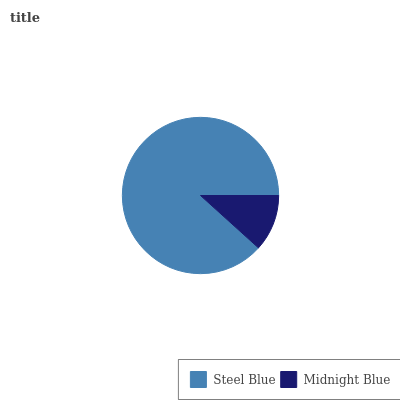Is Midnight Blue the minimum?
Answer yes or no. Yes. Is Steel Blue the maximum?
Answer yes or no. Yes. Is Midnight Blue the maximum?
Answer yes or no. No. Is Steel Blue greater than Midnight Blue?
Answer yes or no. Yes. Is Midnight Blue less than Steel Blue?
Answer yes or no. Yes. Is Midnight Blue greater than Steel Blue?
Answer yes or no. No. Is Steel Blue less than Midnight Blue?
Answer yes or no. No. Is Steel Blue the high median?
Answer yes or no. Yes. Is Midnight Blue the low median?
Answer yes or no. Yes. Is Midnight Blue the high median?
Answer yes or no. No. Is Steel Blue the low median?
Answer yes or no. No. 